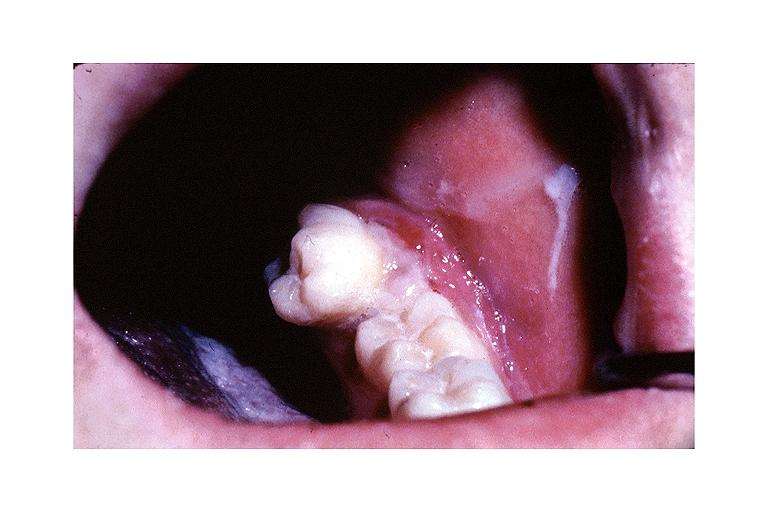what is present?
Answer the question using a single word or phrase. Oral 